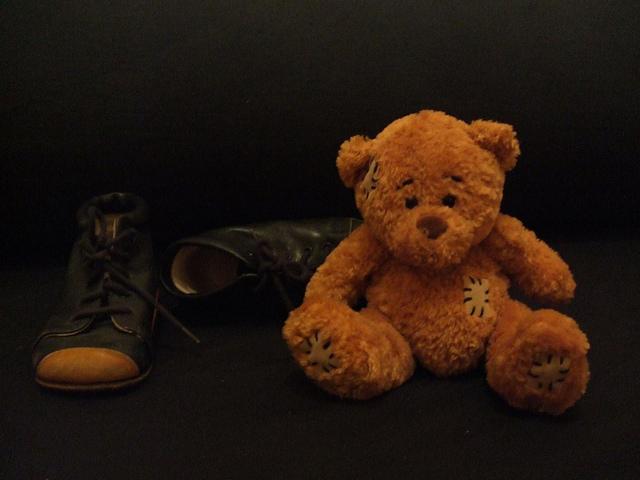Has this bear been well worn?
Answer briefly. Yes. How many teddy bears?
Give a very brief answer. 1. Do you see a human in the picture?
Short answer required. No. Are both shoes standing up?
Be succinct. No. How many of the teddy bears have pants?
Keep it brief. 0. What kind of animal is in this image?
Be succinct. Bear. Is the teddy bear bigger than the shoes?
Be succinct. Yes. 